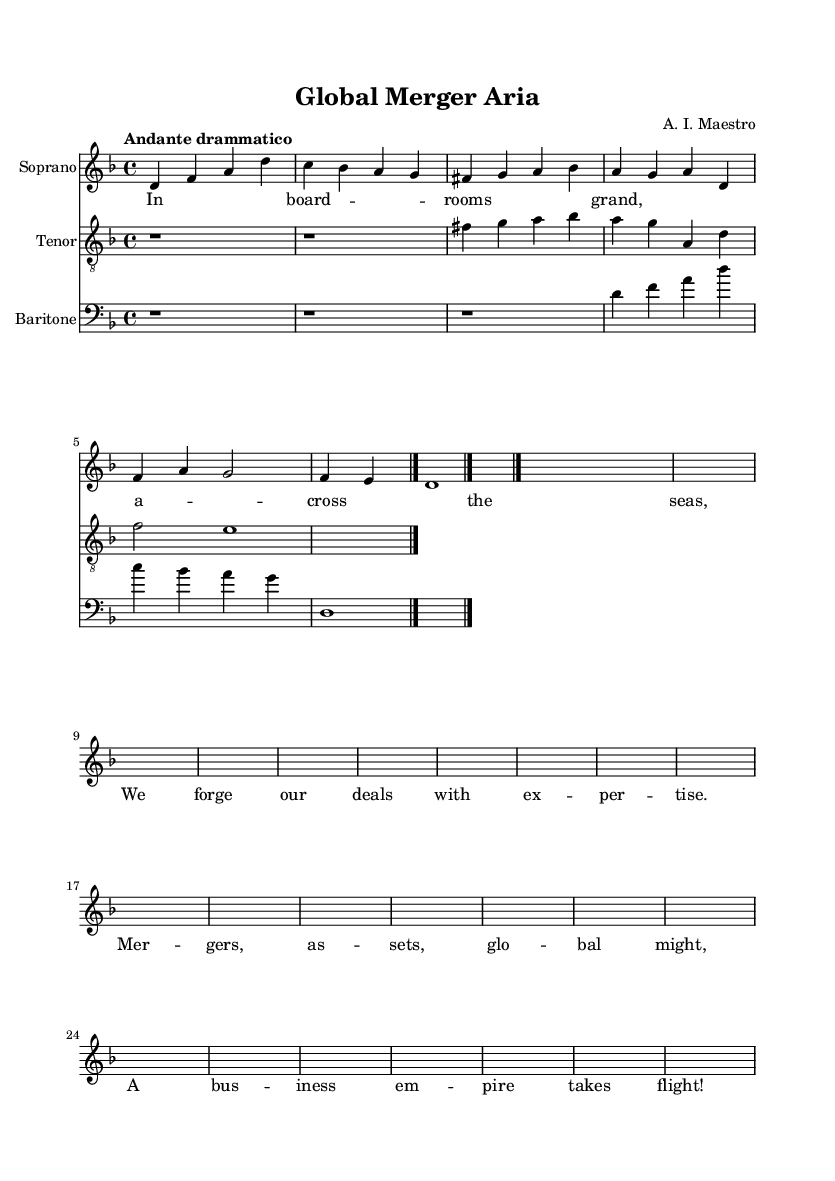What is the key signature of this music? The key signature is indicated by the presence of two flats at the beginning of the score, which corresponds to B flat and E flat, defining D minor.
Answer: D minor What is the time signature of this music? The time signature is indicated in the beginning of the score by the notation "4/4", which means there are four beats in a measure and the quarter note gets the beat.
Answer: 4/4 What is the tempo marking for this piece? The tempo marking is present at the beginning of the score as "Andante drammatico", which suggests a moderately slow and dramatic pace for the performance.
Answer: Andante drammatico How many voices are indicated in this score? The score clearly labels three distinct staves for different vocal parts: Soprano, Tenor, and Baritone, indicating the presence of three voices throughout the piece.
Answer: Three What is the theme of the soprano's part? The soprano's part begins with a melodic line described as "negotiationTheme", which conveys the idea of discussions and agreements in business, shown in the music notation.
Answer: Negotiation Which lyric reflects the theme of global business? The lyric "A business empire takes flight!" captures the essence of international business negotiations and the ambition typically associated with them, aligning with the opera's theme.
Answer: A business empire takes flight! What type of musical form is represented in the score? The score indicates a structured form typical of opera, showing clear differentiation between the three voices and combining both lyrical and melodic elements, which is characteristic of operatic compositions.
Answer: Operatic structure 